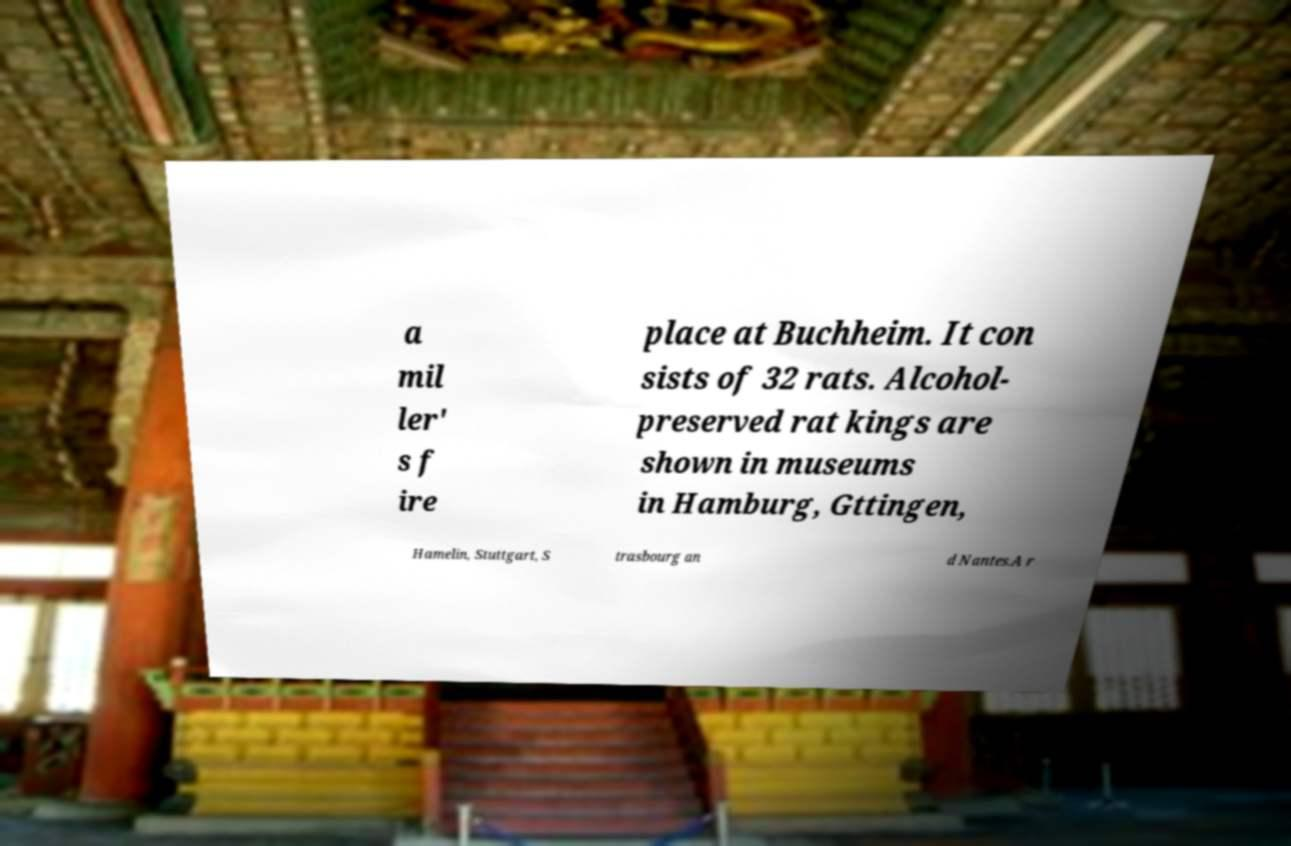Could you extract and type out the text from this image? a mil ler' s f ire place at Buchheim. It con sists of 32 rats. Alcohol- preserved rat kings are shown in museums in Hamburg, Gttingen, Hamelin, Stuttgart, S trasbourg an d Nantes.A r 